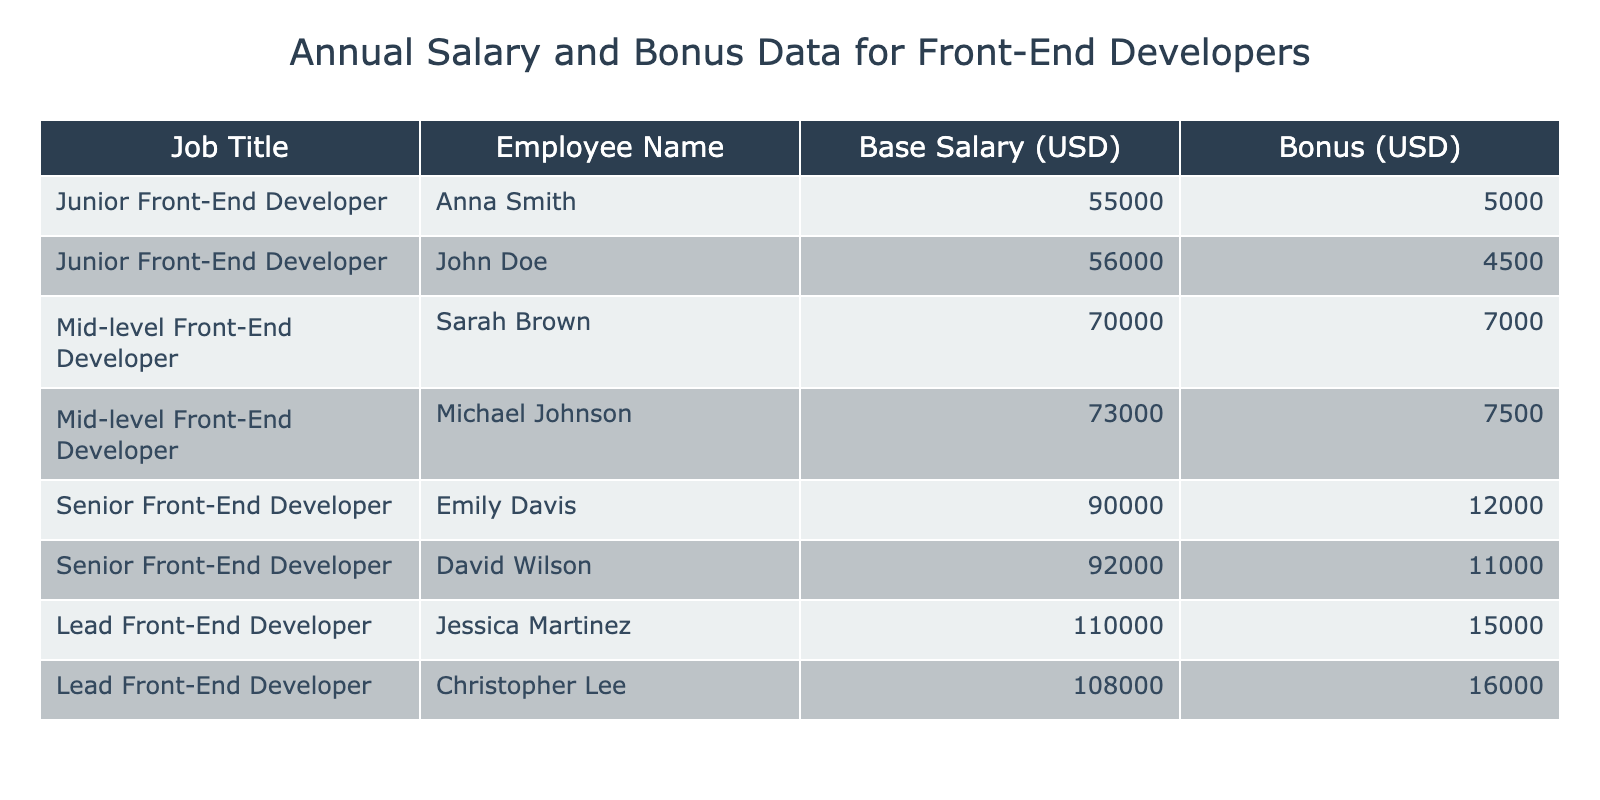What is the base salary of the Senior Front-End Developer named Emily Davis? The table directly lists the base salary for each employee, and for Emily Davis, it is stated as 90000 USD.
Answer: 90000 USD What is the total bonus for all Junior Front-End Developers? The bonuses for Junior Front-End Developers (Anna Smith and John Doe) are 5000 USD and 4500 USD, respectively. Therefore, the total bonus is 5000 + 4500 = 9500 USD.
Answer: 9500 USD Is Sarah Brown's base salary greater than Michael Johnson's base salary? Sarah Brown has a base salary of 70000 USD, while Michael Johnson has a base salary of 73000 USD. Since 70000 is less than 73000, the statement is false.
Answer: No What is the average base salary for Mid-level Front-End Developers? The base salaries for Mid-level Front-End Developers (Sarah Brown and Michael Johnson) are 70000 USD and 73000 USD. To find the average, add them together: 70000 + 73000 = 143000 USD. Then divide by 2 (the number of developers): 143000 / 2 = 71500 USD.
Answer: 71500 USD Which employee has the highest total compensation (base salary plus bonus)? To determine this, we need to calculate the total compensation for each employee. For the highest paid employee, look at Lead Front-End Developer Jessica Martinez, whose total is 110000 (base salary) + 15000 (bonus) = 125000 USD. Checking others confirms Jessica has the highest.
Answer: Jessica Martinez What is the median base salary among all Front-End Developers listed? The base salaries listed are: 55000, 56000, 70000, 73000, 90000, 92000, 110000, and 108000. To find the median, we arrange them in ascending order: 55000, 56000, 70000, 73000, 90000, 92000, 108000, 110000. With 8 entries, the median will be the average of the 4th and 5th values: (73000 + 90000) / 2 = 81500 USD.
Answer: 81500 USD Do Lead Front-End Developers have a bonus higher than 10000 USD? Both Lead Front-End Developers, Jessica Martinez and Christopher Lee, have bonuses of 15000 USD and 16000 USD respectively, both of which are higher than 10000 USD. Thus, the answer to the question is true.
Answer: Yes What is the difference in total compensation between the lowest paid Junior Front-End Developer and the highest paid Lead Front-End Developer? The lowest paid Junior Front-End Developer is Anna Smith with a total compensation of 55000 (base salary) + 5000 (bonus) = 60000 USD. For the highest paid Lead Front-End Developer, Jessica Martinez has a total of 110000 + 15000 = 125000 USD. The difference is 125000 - 60000 = 65000 USD.
Answer: 65000 USD 